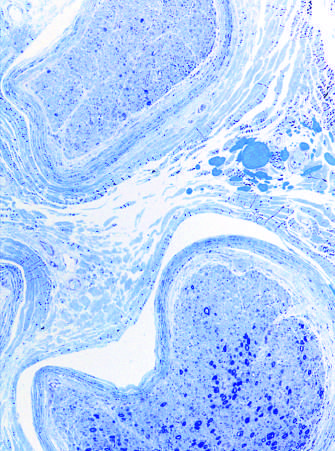what is such interfascicular variation in axonal density often seen in?
Answer the question using a single word or phrase. Neuropathies resulting from vascular injury 